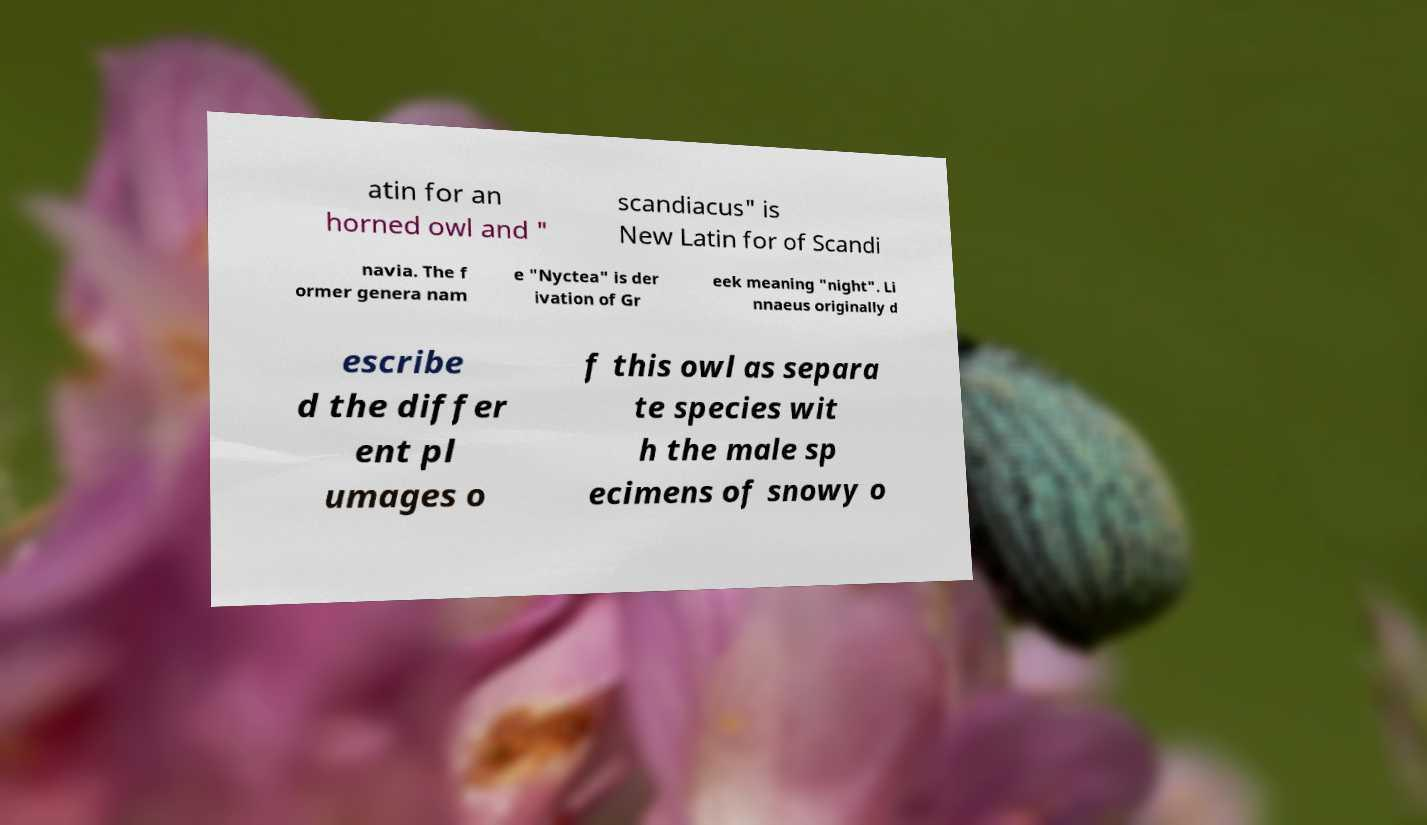I need the written content from this picture converted into text. Can you do that? atin for an horned owl and " scandiacus" is New Latin for of Scandi navia. The f ormer genera nam e "Nyctea" is der ivation of Gr eek meaning "night". Li nnaeus originally d escribe d the differ ent pl umages o f this owl as separa te species wit h the male sp ecimens of snowy o 